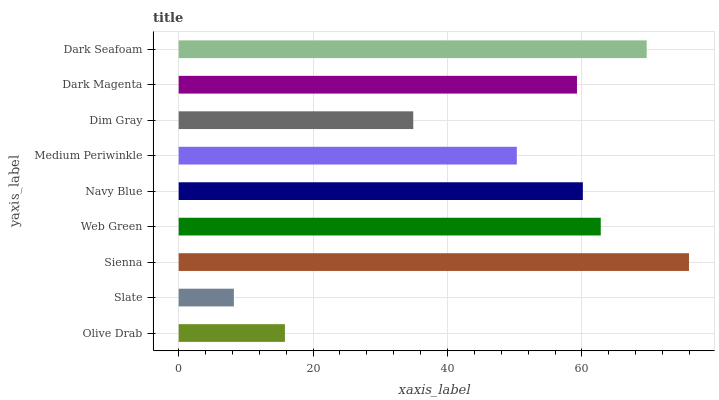Is Slate the minimum?
Answer yes or no. Yes. Is Sienna the maximum?
Answer yes or no. Yes. Is Sienna the minimum?
Answer yes or no. No. Is Slate the maximum?
Answer yes or no. No. Is Sienna greater than Slate?
Answer yes or no. Yes. Is Slate less than Sienna?
Answer yes or no. Yes. Is Slate greater than Sienna?
Answer yes or no. No. Is Sienna less than Slate?
Answer yes or no. No. Is Dark Magenta the high median?
Answer yes or no. Yes. Is Dark Magenta the low median?
Answer yes or no. Yes. Is Medium Periwinkle the high median?
Answer yes or no. No. Is Navy Blue the low median?
Answer yes or no. No. 